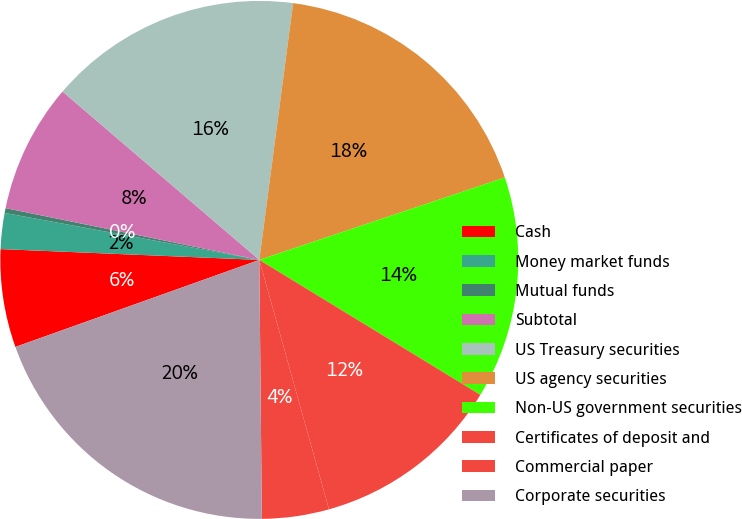Convert chart. <chart><loc_0><loc_0><loc_500><loc_500><pie_chart><fcel>Cash<fcel>Money market funds<fcel>Mutual funds<fcel>Subtotal<fcel>US Treasury securities<fcel>US agency securities<fcel>Non-US government securities<fcel>Certificates of deposit and<fcel>Commercial paper<fcel>Corporate securities<nl><fcel>6.12%<fcel>2.24%<fcel>0.3%<fcel>8.06%<fcel>15.82%<fcel>17.76%<fcel>13.88%<fcel>11.94%<fcel>4.18%<fcel>19.7%<nl></chart> 